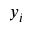<formula> <loc_0><loc_0><loc_500><loc_500>y _ { i }</formula> 